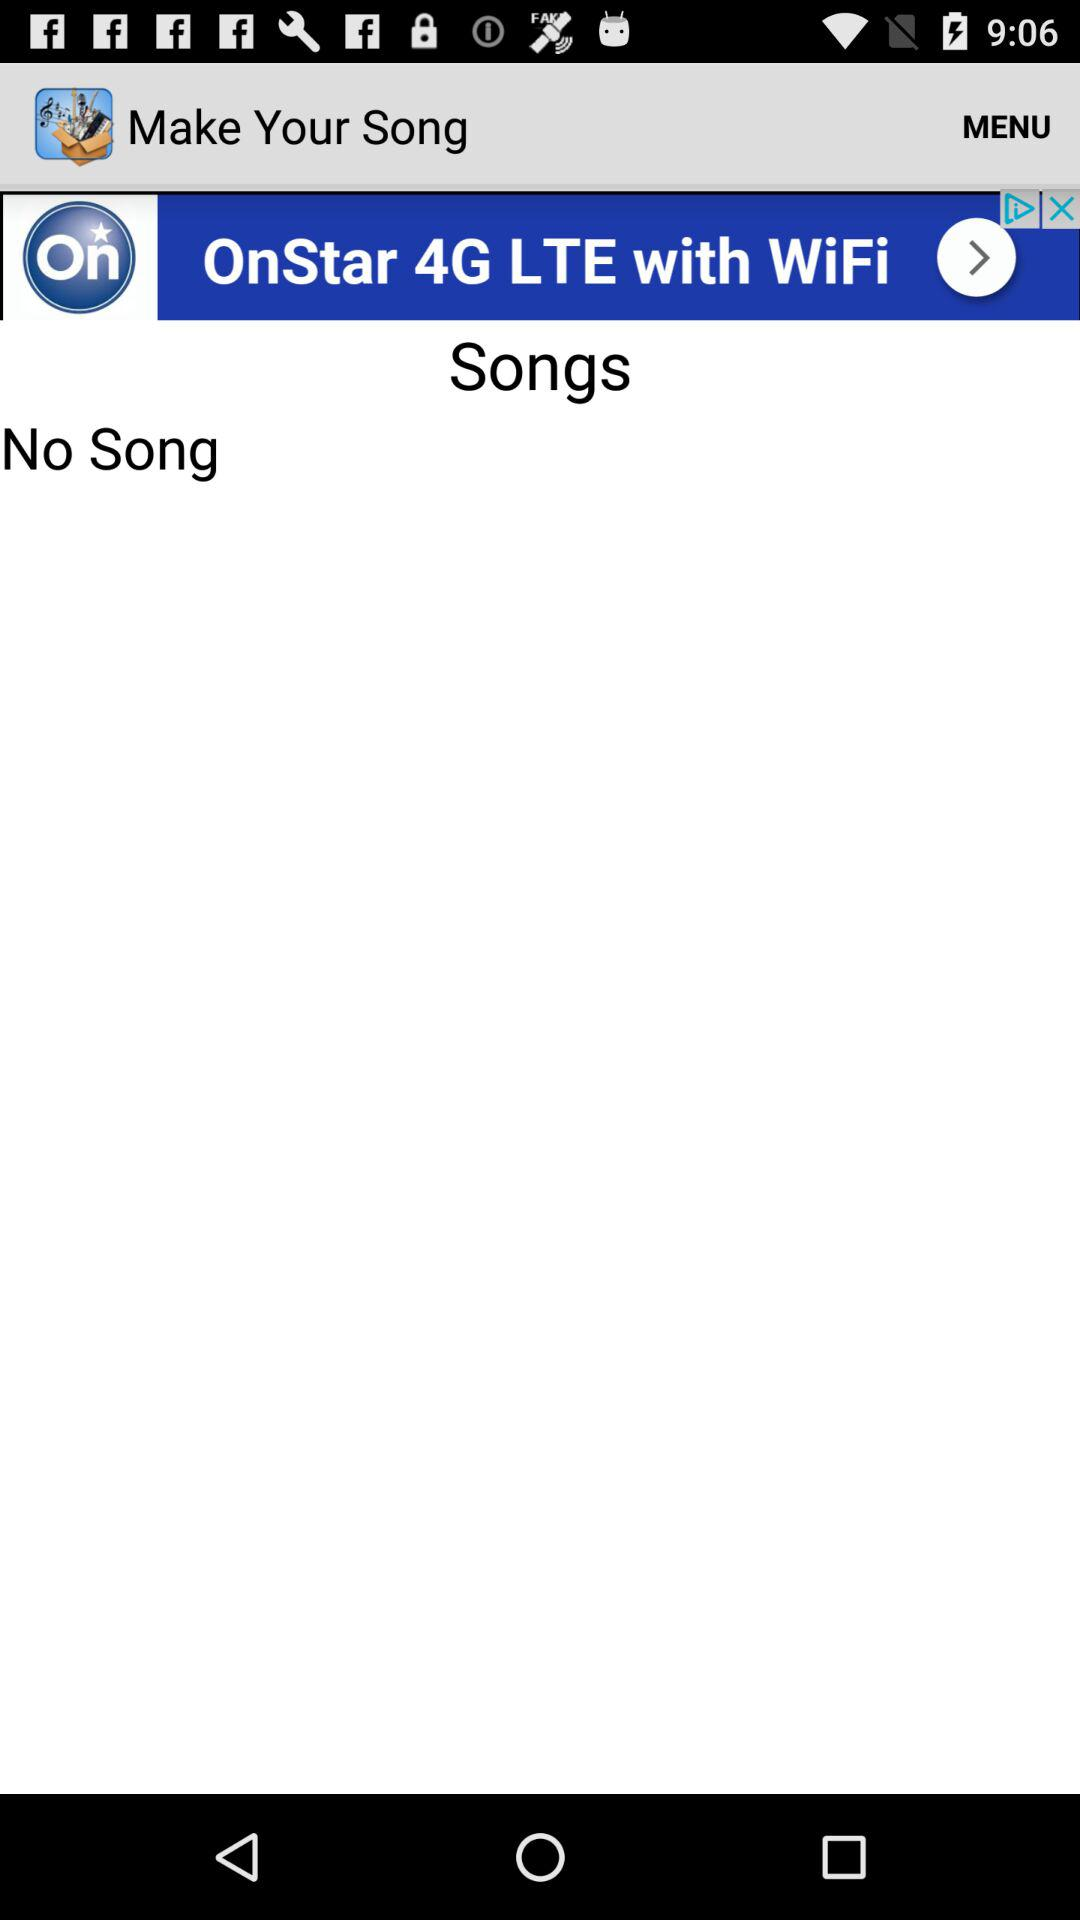Is there any song? There is no song. 